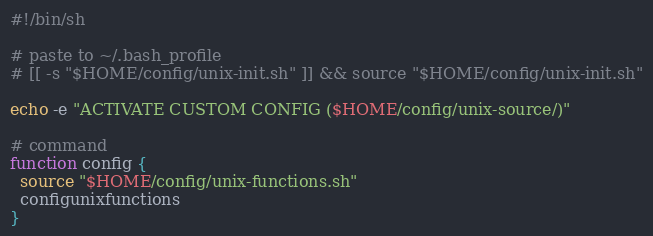<code> <loc_0><loc_0><loc_500><loc_500><_Bash_>#!/bin/sh

# paste to ~/.bash_profile
# [[ -s "$HOME/config/unix-init.sh" ]] && source "$HOME/config/unix-init.sh"

echo -e "ACTIVATE CUSTOM CONFIG ($HOME/config/unix-source/)"

# command
function config {
  source "$HOME/config/unix-functions.sh"
  configunixfunctions
}
</code> 